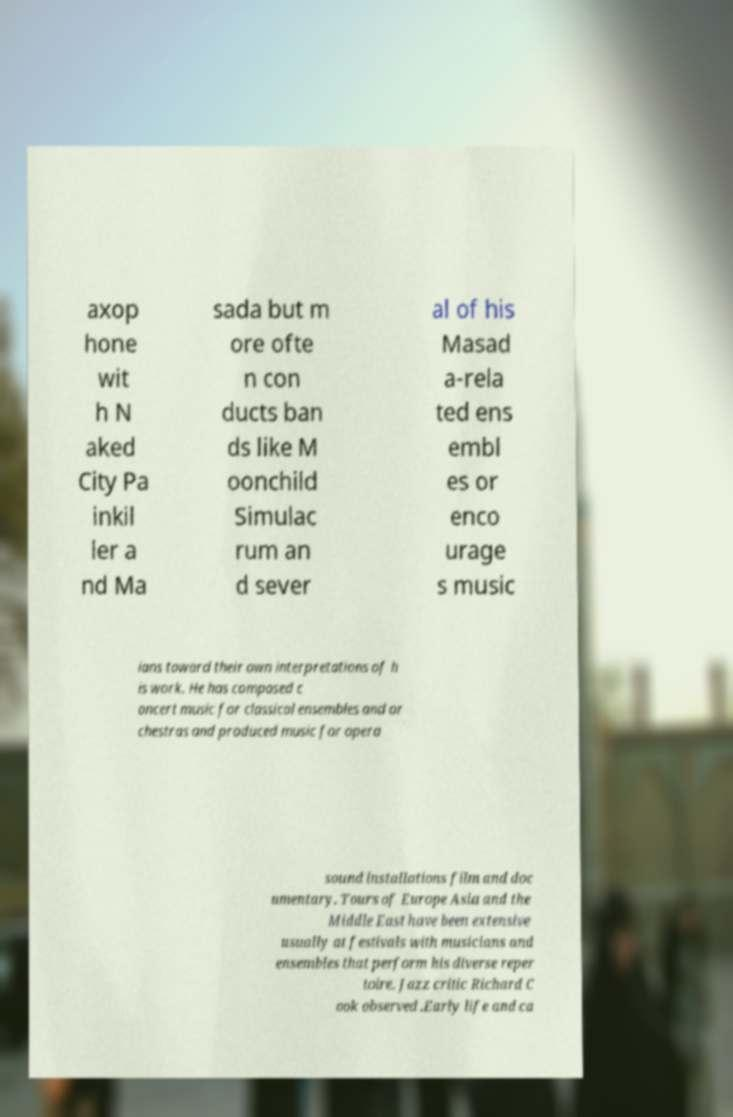Please read and relay the text visible in this image. What does it say? axop hone wit h N aked City Pa inkil ler a nd Ma sada but m ore ofte n con ducts ban ds like M oonchild Simulac rum an d sever al of his Masad a-rela ted ens embl es or enco urage s music ians toward their own interpretations of h is work. He has composed c oncert music for classical ensembles and or chestras and produced music for opera sound installations film and doc umentary. Tours of Europe Asia and the Middle East have been extensive usually at festivals with musicians and ensembles that perform his diverse reper toire. Jazz critic Richard C ook observed .Early life and ca 